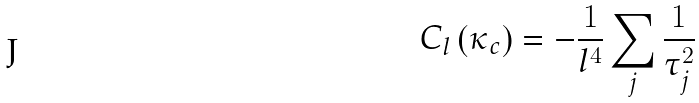Convert formula to latex. <formula><loc_0><loc_0><loc_500><loc_500>C _ { l } \left ( \kappa _ { c } \right ) = - \frac { 1 } { l ^ { 4 } } \sum _ { j } { \frac { 1 } { \tau _ { j } ^ { 2 } } }</formula> 